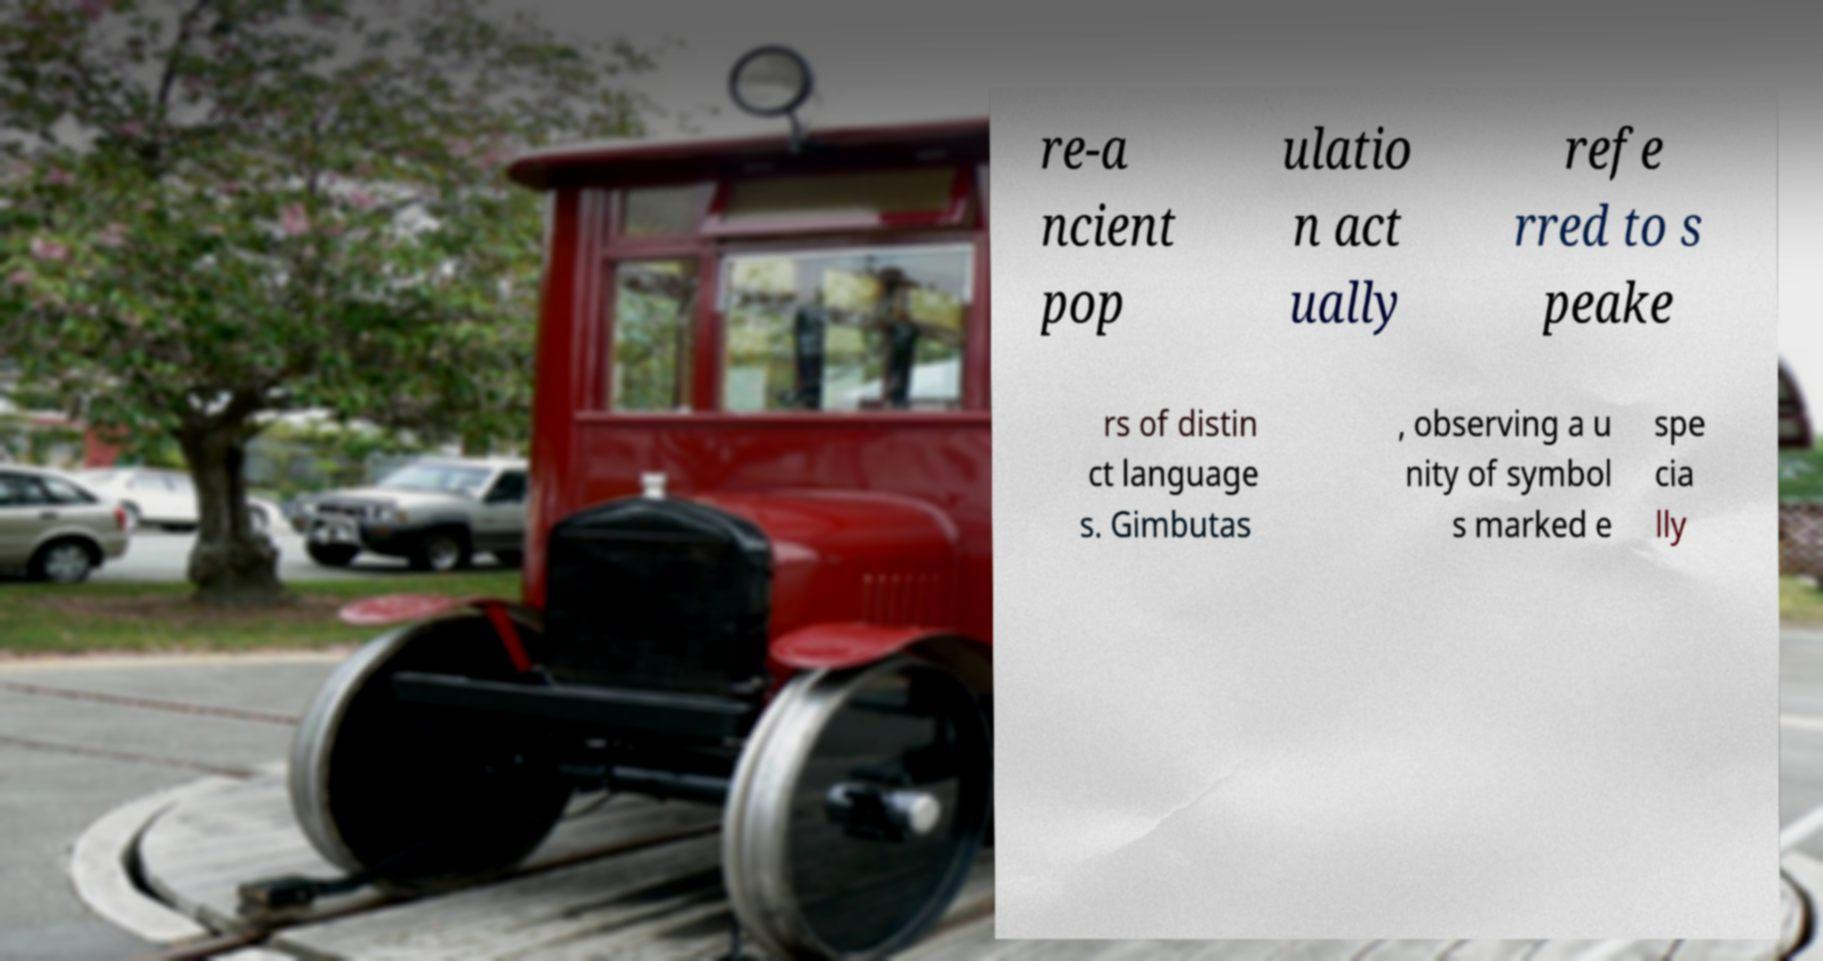Could you assist in decoding the text presented in this image and type it out clearly? re-a ncient pop ulatio n act ually refe rred to s peake rs of distin ct language s. Gimbutas , observing a u nity of symbol s marked e spe cia lly 